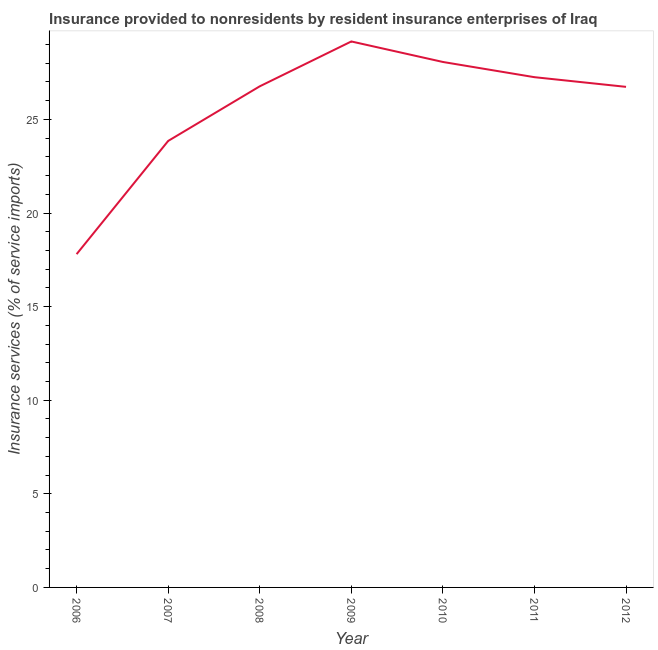What is the insurance and financial services in 2010?
Offer a terse response. 28.07. Across all years, what is the maximum insurance and financial services?
Give a very brief answer. 29.16. Across all years, what is the minimum insurance and financial services?
Keep it short and to the point. 17.8. In which year was the insurance and financial services maximum?
Keep it short and to the point. 2009. What is the sum of the insurance and financial services?
Provide a succinct answer. 179.65. What is the difference between the insurance and financial services in 2006 and 2012?
Provide a short and direct response. -8.94. What is the average insurance and financial services per year?
Provide a short and direct response. 25.66. What is the median insurance and financial services?
Keep it short and to the point. 26.77. In how many years, is the insurance and financial services greater than 7 %?
Keep it short and to the point. 7. What is the ratio of the insurance and financial services in 2007 to that in 2009?
Provide a succinct answer. 0.82. Is the difference between the insurance and financial services in 2006 and 2008 greater than the difference between any two years?
Offer a terse response. No. What is the difference between the highest and the second highest insurance and financial services?
Keep it short and to the point. 1.1. What is the difference between the highest and the lowest insurance and financial services?
Keep it short and to the point. 11.36. In how many years, is the insurance and financial services greater than the average insurance and financial services taken over all years?
Keep it short and to the point. 5. How many years are there in the graph?
Provide a short and direct response. 7. What is the difference between two consecutive major ticks on the Y-axis?
Offer a very short reply. 5. Are the values on the major ticks of Y-axis written in scientific E-notation?
Offer a terse response. No. What is the title of the graph?
Your answer should be compact. Insurance provided to nonresidents by resident insurance enterprises of Iraq. What is the label or title of the Y-axis?
Offer a terse response. Insurance services (% of service imports). What is the Insurance services (% of service imports) in 2006?
Your response must be concise. 17.8. What is the Insurance services (% of service imports) in 2007?
Provide a short and direct response. 23.85. What is the Insurance services (% of service imports) of 2008?
Keep it short and to the point. 26.77. What is the Insurance services (% of service imports) in 2009?
Your answer should be compact. 29.16. What is the Insurance services (% of service imports) of 2010?
Your response must be concise. 28.07. What is the Insurance services (% of service imports) of 2011?
Provide a short and direct response. 27.26. What is the Insurance services (% of service imports) of 2012?
Your response must be concise. 26.74. What is the difference between the Insurance services (% of service imports) in 2006 and 2007?
Make the answer very short. -6.05. What is the difference between the Insurance services (% of service imports) in 2006 and 2008?
Keep it short and to the point. -8.97. What is the difference between the Insurance services (% of service imports) in 2006 and 2009?
Give a very brief answer. -11.36. What is the difference between the Insurance services (% of service imports) in 2006 and 2010?
Your response must be concise. -10.27. What is the difference between the Insurance services (% of service imports) in 2006 and 2011?
Offer a very short reply. -9.45. What is the difference between the Insurance services (% of service imports) in 2006 and 2012?
Make the answer very short. -8.94. What is the difference between the Insurance services (% of service imports) in 2007 and 2008?
Ensure brevity in your answer.  -2.92. What is the difference between the Insurance services (% of service imports) in 2007 and 2009?
Provide a short and direct response. -5.31. What is the difference between the Insurance services (% of service imports) in 2007 and 2010?
Offer a terse response. -4.22. What is the difference between the Insurance services (% of service imports) in 2007 and 2011?
Keep it short and to the point. -3.41. What is the difference between the Insurance services (% of service imports) in 2007 and 2012?
Offer a very short reply. -2.89. What is the difference between the Insurance services (% of service imports) in 2008 and 2009?
Offer a very short reply. -2.4. What is the difference between the Insurance services (% of service imports) in 2008 and 2010?
Ensure brevity in your answer.  -1.3. What is the difference between the Insurance services (% of service imports) in 2008 and 2011?
Keep it short and to the point. -0.49. What is the difference between the Insurance services (% of service imports) in 2008 and 2012?
Provide a short and direct response. 0.03. What is the difference between the Insurance services (% of service imports) in 2009 and 2010?
Offer a terse response. 1.1. What is the difference between the Insurance services (% of service imports) in 2009 and 2011?
Make the answer very short. 1.91. What is the difference between the Insurance services (% of service imports) in 2009 and 2012?
Your response must be concise. 2.42. What is the difference between the Insurance services (% of service imports) in 2010 and 2011?
Your answer should be very brief. 0.81. What is the difference between the Insurance services (% of service imports) in 2010 and 2012?
Give a very brief answer. 1.33. What is the difference between the Insurance services (% of service imports) in 2011 and 2012?
Provide a short and direct response. 0.52. What is the ratio of the Insurance services (% of service imports) in 2006 to that in 2007?
Your response must be concise. 0.75. What is the ratio of the Insurance services (% of service imports) in 2006 to that in 2008?
Your response must be concise. 0.67. What is the ratio of the Insurance services (% of service imports) in 2006 to that in 2009?
Provide a succinct answer. 0.61. What is the ratio of the Insurance services (% of service imports) in 2006 to that in 2010?
Give a very brief answer. 0.63. What is the ratio of the Insurance services (% of service imports) in 2006 to that in 2011?
Keep it short and to the point. 0.65. What is the ratio of the Insurance services (% of service imports) in 2006 to that in 2012?
Provide a succinct answer. 0.67. What is the ratio of the Insurance services (% of service imports) in 2007 to that in 2008?
Keep it short and to the point. 0.89. What is the ratio of the Insurance services (% of service imports) in 2007 to that in 2009?
Give a very brief answer. 0.82. What is the ratio of the Insurance services (% of service imports) in 2007 to that in 2011?
Provide a succinct answer. 0.88. What is the ratio of the Insurance services (% of service imports) in 2007 to that in 2012?
Your response must be concise. 0.89. What is the ratio of the Insurance services (% of service imports) in 2008 to that in 2009?
Your answer should be compact. 0.92. What is the ratio of the Insurance services (% of service imports) in 2008 to that in 2010?
Make the answer very short. 0.95. What is the ratio of the Insurance services (% of service imports) in 2009 to that in 2010?
Your response must be concise. 1.04. What is the ratio of the Insurance services (% of service imports) in 2009 to that in 2011?
Offer a terse response. 1.07. What is the ratio of the Insurance services (% of service imports) in 2009 to that in 2012?
Keep it short and to the point. 1.09. What is the ratio of the Insurance services (% of service imports) in 2010 to that in 2012?
Offer a very short reply. 1.05. What is the ratio of the Insurance services (% of service imports) in 2011 to that in 2012?
Offer a terse response. 1.02. 